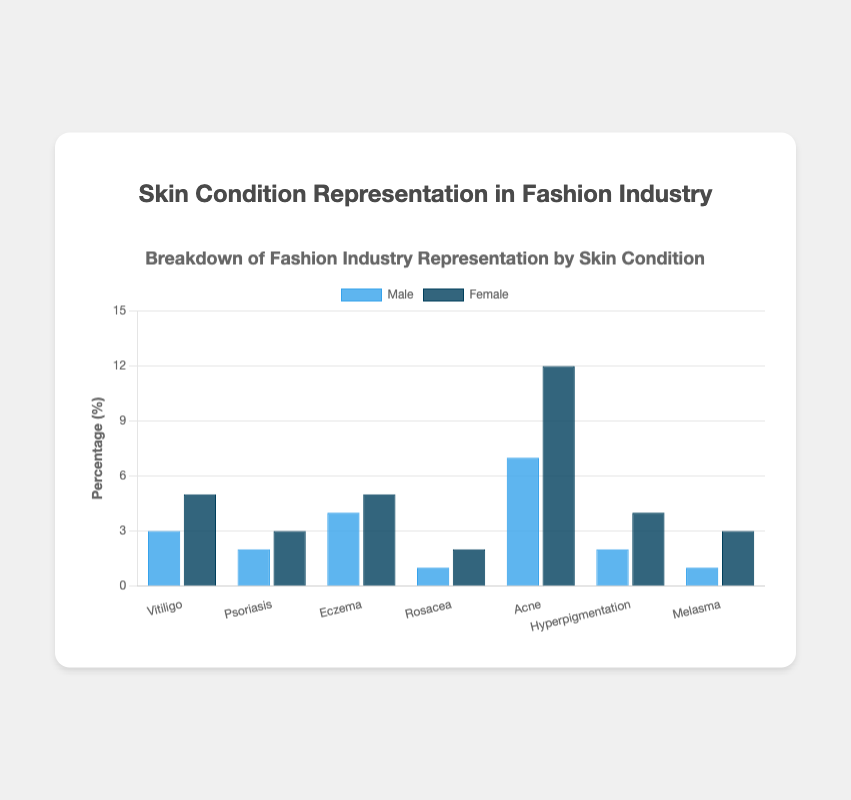What skin condition has the highest representation of female models? The bar representing acne for female models is the tallest among all, suggesting it has the highest representation.
Answer: Acne What is the total percentage representation of male and female models with Vitiligo? The percentage of male models with Vitiligo is 3% and for female models, it is 5%. Adding these values gives us the total percentage.
Answer: 8% How much higher is the female representation compared to the male representation for Eczema? The percentage of female models with Eczema is 5% while that of male models is 4%. The difference is calculated as 5% - 4%.
Answer: 1% Which has a greater combined representation: models with Rosacea or models with Psoriasis? For Rosacea: Male (1%) + Female (2%) = 3%; For Psoriasis: Male (2%) + Female (3%) = 5%. Therefore, Psoriasis has a greater combined representation.
Answer: Psoriasis Are there any conditions where male representation is greater than female representation? If yes, which one(s)? Analyzing the bars, none of the male percentages are greater than their corresponding female percentages.
Answer: No What is the visual difference in bar height between the male and female representation of models with Hyperpigmentation? The male bar height for Hyperpigmentation is represented by 2% and the female by 4%. The visual difference is the additional height up to 4%.
Answer: 2% What condition has the least combined percentage of representation in the fashion industry? Adding male and female percentages for each condition, Melasma has the least: 1% (Male) + 3% (Female) = 4%.
Answer: Melasma Is the representation gap between male and female models largest for Acne? For Acne: Female (12%) - Male (7%) = 5%, and scanning through other conditions confirms that 5% is the largest gap.
Answer: Yes What is the average male representation across all conditions? Sum of male percentages is: 3 + 2 + 4 + 1 + 7 + 2 + 1 = 20. Dividing by the number of conditions (7) gives the average: 20/7 ≈ 2.86.
Answer: 2.86% How does the female representation for Psoriasis compare to that of Rosacea? The female representation for Psoriasis is represented by 3%, whereas for Rosacea it is 2%. Therefore, Psoriasis has a higher female representation.
Answer: Psoriasis 